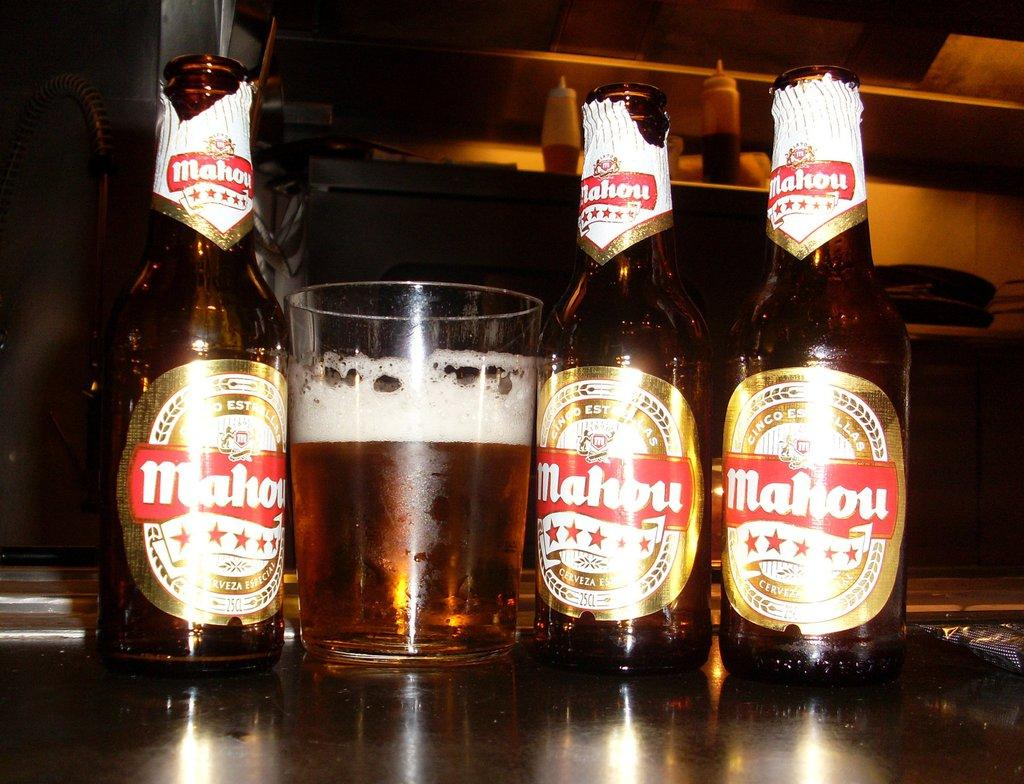<image>
Render a clear and concise summary of the photo. Sitting on a bar there is three bottles of Malhou beer and one glass of beer sitting in a row. 